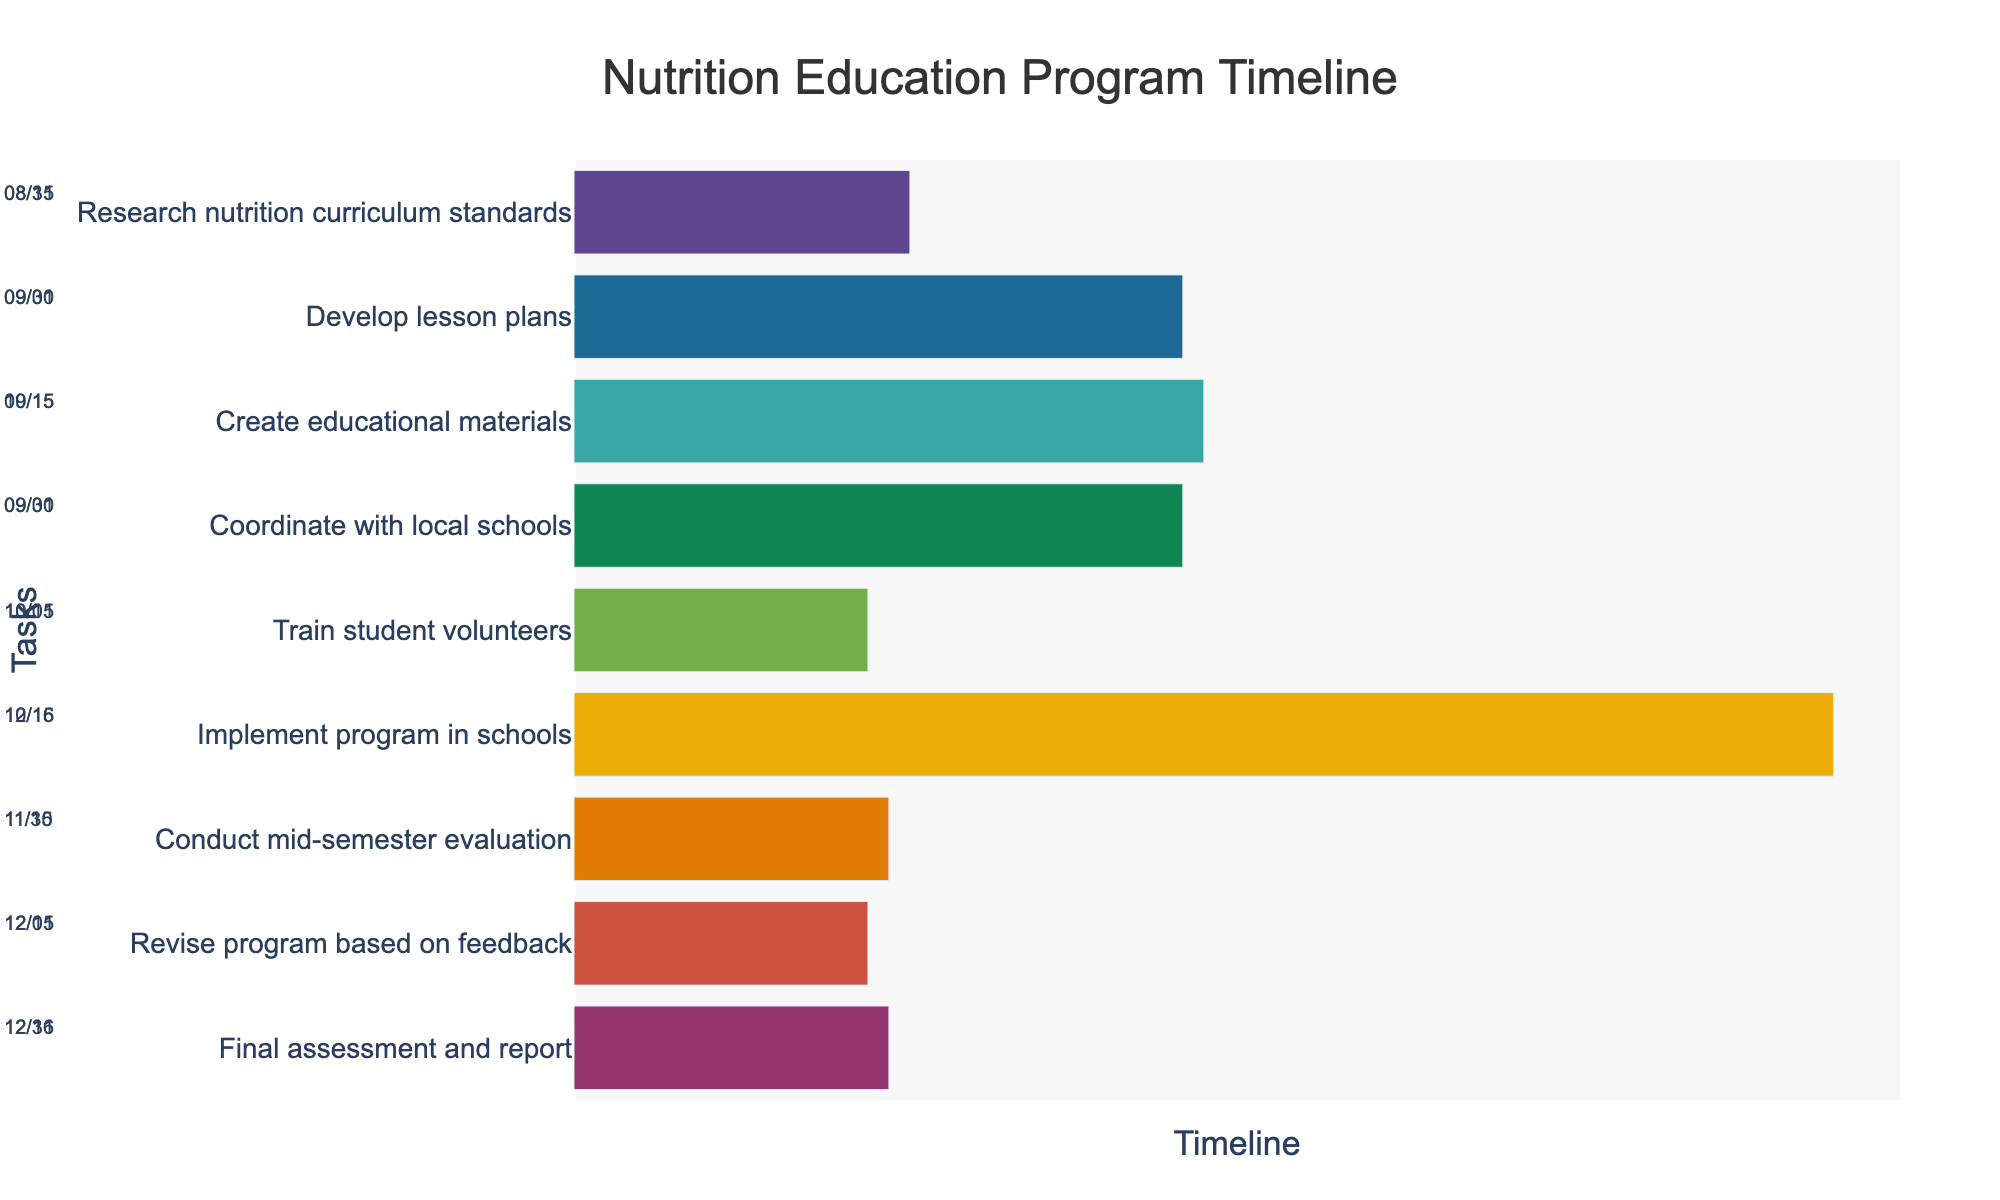Which task begins the earliest? By examining the start dates on the Gantt chart, we see that "Research nutrition curriculum standards" begins on 2023-08-15, which is earlier than any other task.
Answer: Research nutrition curriculum standards Which tasks end in October? According to the end dates, the tasks "Create educational materials" and "Train student volunteers" both end in October, specifically on 2023-10-15.
Answer: Create educational materials, Train student volunteers When does the "Implement program in schools" task start and end? By looking at the bar labeled "Implement program in schools," we find that it starts on 2023-10-16 and ends on 2023-12-15. The start and end dates are usually indicated at the edges of the Gantt bar.
Answer: Starts on 2023-10-16, ends on 2023-12-15 Which task has the longest duration? The duration of each task is represented by the length of its respective bar. "Implement program in schools" lasts from 2023-10-16 to 2023-12-15, which is approximately 60 days, making it the longest.
Answer: Implement program in schools How many days are allocated for "Revise program based on feedback"? "Revise program based on feedback" starts on 2023-12-01 and ends on 2023-12-15. The difference is 14 days.
Answer: 14 days Which two tasks overlap entirely within the month of September? By observing the timeline, "Develop lesson plans" and "Coordinate with local schools" both start on 2023-09-01 and end on 2023-09-30, indicating that they overlap entirely within September.
Answer: Develop lesson plans, Coordinate with local schools During which tasks is "Create educational materials" concurrent? "Create educational materials" runs from 2023-09-15 to 2023-10-15. During this period, it overlaps with "Develop lesson plans," "Coordinate with local schools," and "Train student volunteers."
Answer: Develop lesson plans, Coordinate with local schools, Train student volunteers When should the mid-semester evaluation be conducted according to the plan? The bar for "Conduct mid-semester evaluation" indicates that it should be done between 2023-11-15 and 2023-11-30.
Answer: 2023-11-15 to 2023-11-30 What is the title of the Gantt chart? The title is usually positioned at the top center of the plot. In this case, the title is "Nutrition Education Program Timeline."
Answer: Nutrition Education Program Timeline 